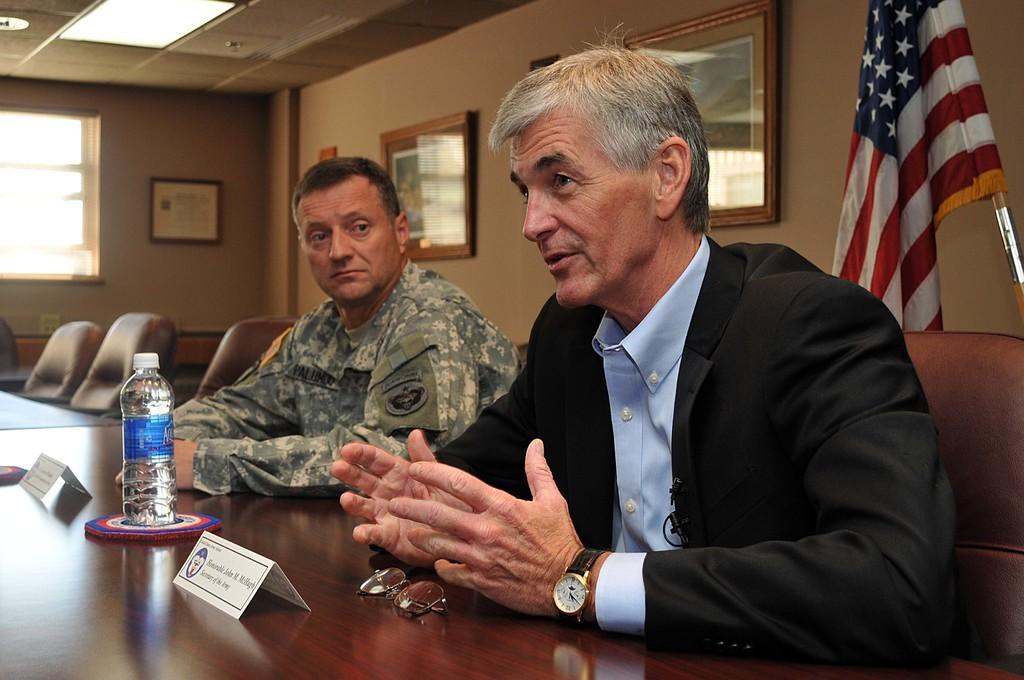Can you describe this image briefly? in this image i can see 2 men sitting. in-front of them there is a table and a water-bottle, spectacles. behind them there is a British flag and on the wall there are photo frames. on the left side there is a window. 